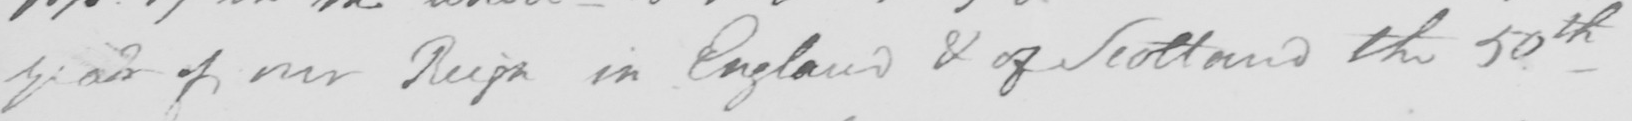What does this handwritten line say? year of our Reign in England & of Scotland the 50th 